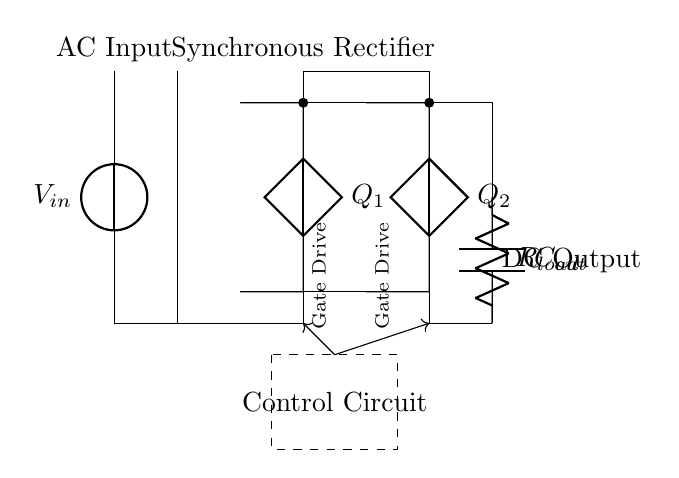What type of rectifier is shown in the diagram? The diagram depicts a synchronous rectifier, which is characterized by its use of controlled switches to convert AC to DC more efficiently than traditional diodes.
Answer: Synchronous rectifier How many gate drive signals are present in the circuit? There are two gate drive signals, each controlling one of the two switches (Q1 and Q2) in the synchronous rectifier for optimal switching.
Answer: Two What is the role of the control circuit in this design? The control circuit generates the gate drive signals that control the operation of the synchronous rectifier switches, allowing for improved energy conversion by synchronizing their on/off states with the AC input.
Answer: Gate control What is the load connected to the output of the circuit? The load is represented by a resistor and a capacitor in parallel, ensuring the output can supply a stable DC voltage to the load.
Answer: Resistor and capacitor What component type is Q1 and Q2 in this rectifier circuit? Q1 and Q2 are typically MOSFETs or other types of controlled switches that operate based on the gate drive signals.
Answer: Controlled switches What is the power conversion efficiency aim of this synchronous rectifier design? The aim is to maximize energy conversion efficiency, generally striving for efficiency rates above ninety percent, minimizing power loss during the rectification process.
Answer: Above ninety percent 